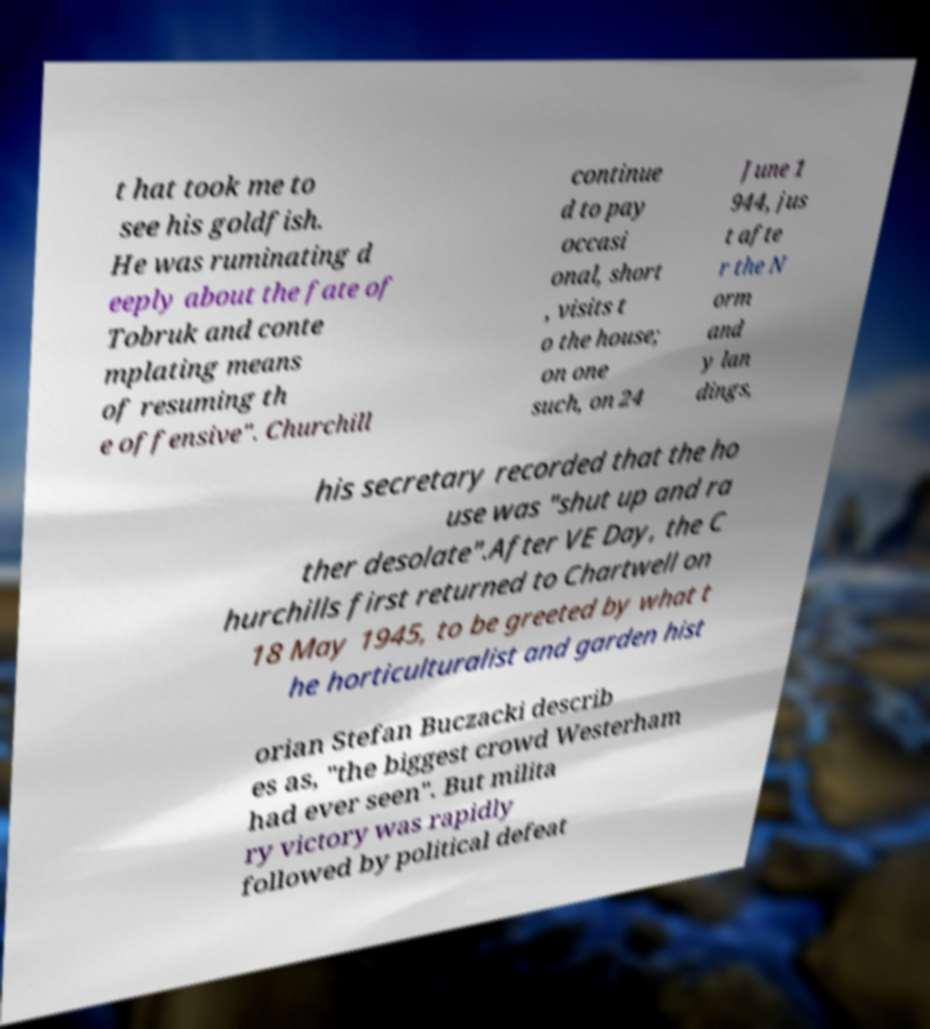Please identify and transcribe the text found in this image. t hat took me to see his goldfish. He was ruminating d eeply about the fate of Tobruk and conte mplating means of resuming th e offensive". Churchill continue d to pay occasi onal, short , visits t o the house; on one such, on 24 June 1 944, jus t afte r the N orm and y lan dings, his secretary recorded that the ho use was "shut up and ra ther desolate".After VE Day, the C hurchills first returned to Chartwell on 18 May 1945, to be greeted by what t he horticulturalist and garden hist orian Stefan Buczacki describ es as, "the biggest crowd Westerham had ever seen". But milita ry victory was rapidly followed by political defeat 